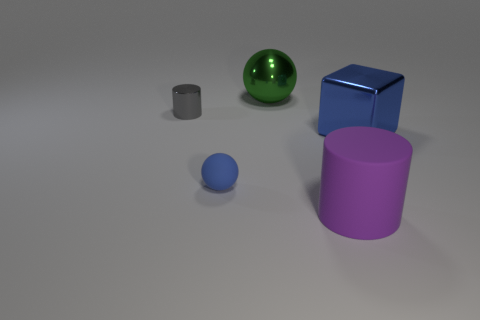Is there any other thing that is the same size as the metallic ball?
Offer a terse response. Yes. Is there any other thing that has the same color as the large ball?
Your answer should be very brief. No. There is a tiny thing that is on the right side of the tiny thing that is behind the cube; what is its color?
Make the answer very short. Blue. There is a large thing that is behind the big shiny object in front of the ball behind the blue block; what is its material?
Offer a very short reply. Metal. How many blue matte balls have the same size as the green metallic object?
Give a very brief answer. 0. What material is the large object that is right of the green shiny object and behind the purple cylinder?
Ensure brevity in your answer.  Metal. How many objects are to the left of the tiny gray cylinder?
Your response must be concise. 0. Do the large blue thing and the blue object that is on the left side of the green sphere have the same shape?
Offer a terse response. No. Are there any cyan objects that have the same shape as the small blue rubber thing?
Your answer should be very brief. No. What shape is the large purple thing that is to the right of the matte thing that is behind the big rubber thing?
Keep it short and to the point. Cylinder. 